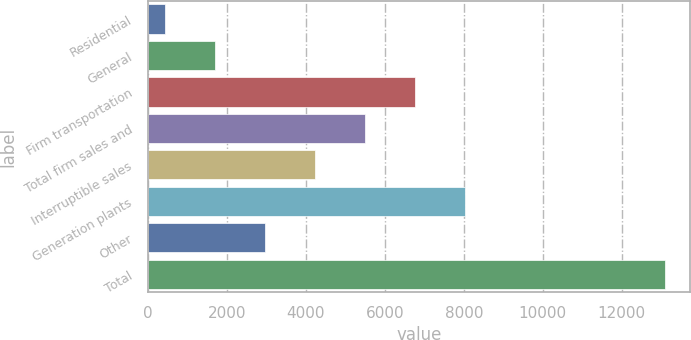Convert chart to OTSL. <chart><loc_0><loc_0><loc_500><loc_500><bar_chart><fcel>Residential<fcel>General<fcel>Firm transportation<fcel>Total firm sales and<fcel>Interruptible sales<fcel>Generation plants<fcel>Other<fcel>Total<nl><fcel>446<fcel>1709.4<fcel>6763<fcel>5499.6<fcel>4236.2<fcel>8026.4<fcel>2972.8<fcel>13080<nl></chart> 